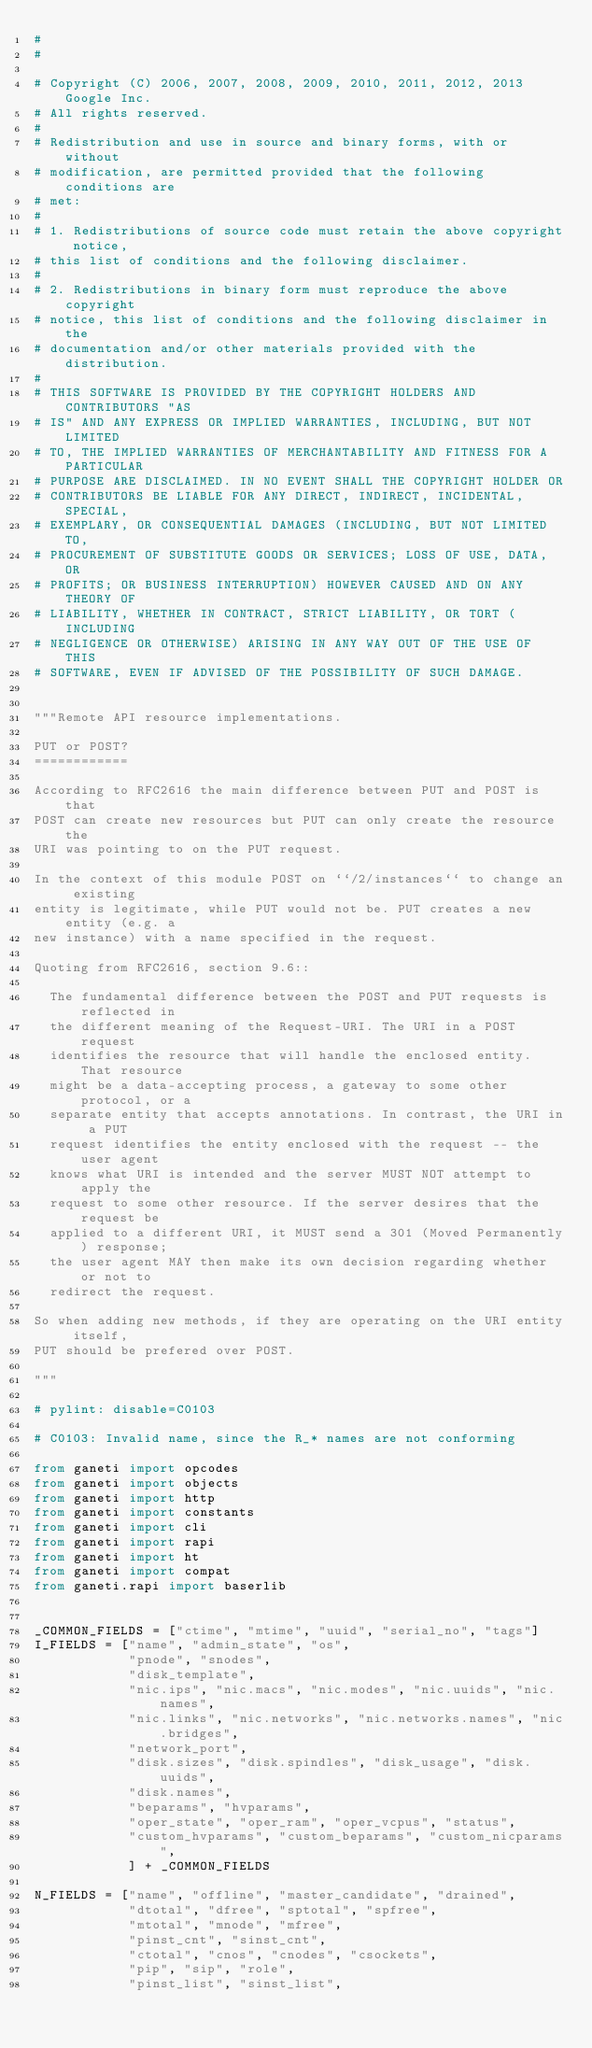<code> <loc_0><loc_0><loc_500><loc_500><_Python_>#
#

# Copyright (C) 2006, 2007, 2008, 2009, 2010, 2011, 2012, 2013 Google Inc.
# All rights reserved.
#
# Redistribution and use in source and binary forms, with or without
# modification, are permitted provided that the following conditions are
# met:
#
# 1. Redistributions of source code must retain the above copyright notice,
# this list of conditions and the following disclaimer.
#
# 2. Redistributions in binary form must reproduce the above copyright
# notice, this list of conditions and the following disclaimer in the
# documentation and/or other materials provided with the distribution.
#
# THIS SOFTWARE IS PROVIDED BY THE COPYRIGHT HOLDERS AND CONTRIBUTORS "AS
# IS" AND ANY EXPRESS OR IMPLIED WARRANTIES, INCLUDING, BUT NOT LIMITED
# TO, THE IMPLIED WARRANTIES OF MERCHANTABILITY AND FITNESS FOR A PARTICULAR
# PURPOSE ARE DISCLAIMED. IN NO EVENT SHALL THE COPYRIGHT HOLDER OR
# CONTRIBUTORS BE LIABLE FOR ANY DIRECT, INDIRECT, INCIDENTAL, SPECIAL,
# EXEMPLARY, OR CONSEQUENTIAL DAMAGES (INCLUDING, BUT NOT LIMITED TO,
# PROCUREMENT OF SUBSTITUTE GOODS OR SERVICES; LOSS OF USE, DATA, OR
# PROFITS; OR BUSINESS INTERRUPTION) HOWEVER CAUSED AND ON ANY THEORY OF
# LIABILITY, WHETHER IN CONTRACT, STRICT LIABILITY, OR TORT (INCLUDING
# NEGLIGENCE OR OTHERWISE) ARISING IN ANY WAY OUT OF THE USE OF THIS
# SOFTWARE, EVEN IF ADVISED OF THE POSSIBILITY OF SUCH DAMAGE.


"""Remote API resource implementations.

PUT or POST?
============

According to RFC2616 the main difference between PUT and POST is that
POST can create new resources but PUT can only create the resource the
URI was pointing to on the PUT request.

In the context of this module POST on ``/2/instances`` to change an existing
entity is legitimate, while PUT would not be. PUT creates a new entity (e.g. a
new instance) with a name specified in the request.

Quoting from RFC2616, section 9.6::

  The fundamental difference between the POST and PUT requests is reflected in
  the different meaning of the Request-URI. The URI in a POST request
  identifies the resource that will handle the enclosed entity. That resource
  might be a data-accepting process, a gateway to some other protocol, or a
  separate entity that accepts annotations. In contrast, the URI in a PUT
  request identifies the entity enclosed with the request -- the user agent
  knows what URI is intended and the server MUST NOT attempt to apply the
  request to some other resource. If the server desires that the request be
  applied to a different URI, it MUST send a 301 (Moved Permanently) response;
  the user agent MAY then make its own decision regarding whether or not to
  redirect the request.

So when adding new methods, if they are operating on the URI entity itself,
PUT should be prefered over POST.

"""

# pylint: disable=C0103

# C0103: Invalid name, since the R_* names are not conforming

from ganeti import opcodes
from ganeti import objects
from ganeti import http
from ganeti import constants
from ganeti import cli
from ganeti import rapi
from ganeti import ht
from ganeti import compat
from ganeti.rapi import baserlib


_COMMON_FIELDS = ["ctime", "mtime", "uuid", "serial_no", "tags"]
I_FIELDS = ["name", "admin_state", "os",
            "pnode", "snodes",
            "disk_template",
            "nic.ips", "nic.macs", "nic.modes", "nic.uuids", "nic.names",
            "nic.links", "nic.networks", "nic.networks.names", "nic.bridges",
            "network_port",
            "disk.sizes", "disk.spindles", "disk_usage", "disk.uuids",
            "disk.names",
            "beparams", "hvparams",
            "oper_state", "oper_ram", "oper_vcpus", "status",
            "custom_hvparams", "custom_beparams", "custom_nicparams",
            ] + _COMMON_FIELDS

N_FIELDS = ["name", "offline", "master_candidate", "drained",
            "dtotal", "dfree", "sptotal", "spfree",
            "mtotal", "mnode", "mfree",
            "pinst_cnt", "sinst_cnt",
            "ctotal", "cnos", "cnodes", "csockets",
            "pip", "sip", "role",
            "pinst_list", "sinst_list",</code> 